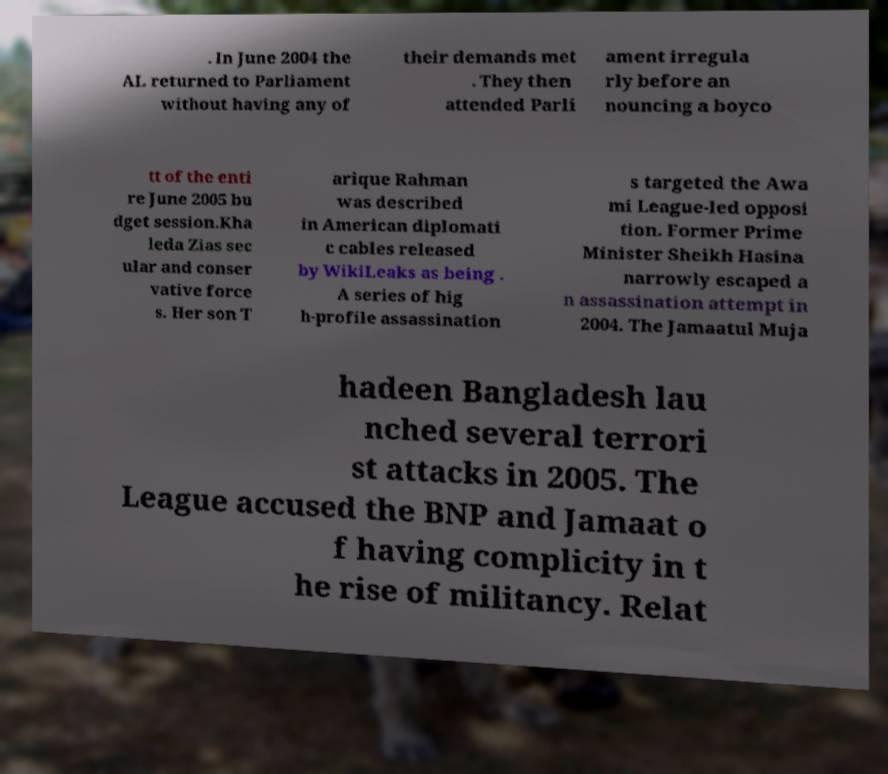Please read and relay the text visible in this image. What does it say? . In June 2004 the AL returned to Parliament without having any of their demands met . They then attended Parli ament irregula rly before an nouncing a boyco tt of the enti re June 2005 bu dget session.Kha leda Zias sec ular and conser vative force s. Her son T arique Rahman was described in American diplomati c cables released by WikiLeaks as being . A series of hig h-profile assassination s targeted the Awa mi League-led opposi tion. Former Prime Minister Sheikh Hasina narrowly escaped a n assassination attempt in 2004. The Jamaatul Muja hadeen Bangladesh lau nched several terrori st attacks in 2005. The League accused the BNP and Jamaat o f having complicity in t he rise of militancy. Relat 